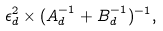Convert formula to latex. <formula><loc_0><loc_0><loc_500><loc_500>\epsilon _ { d } ^ { 2 } \times ( A _ { d } ^ { - 1 } + B _ { d } ^ { - 1 } ) ^ { - 1 } ,</formula> 